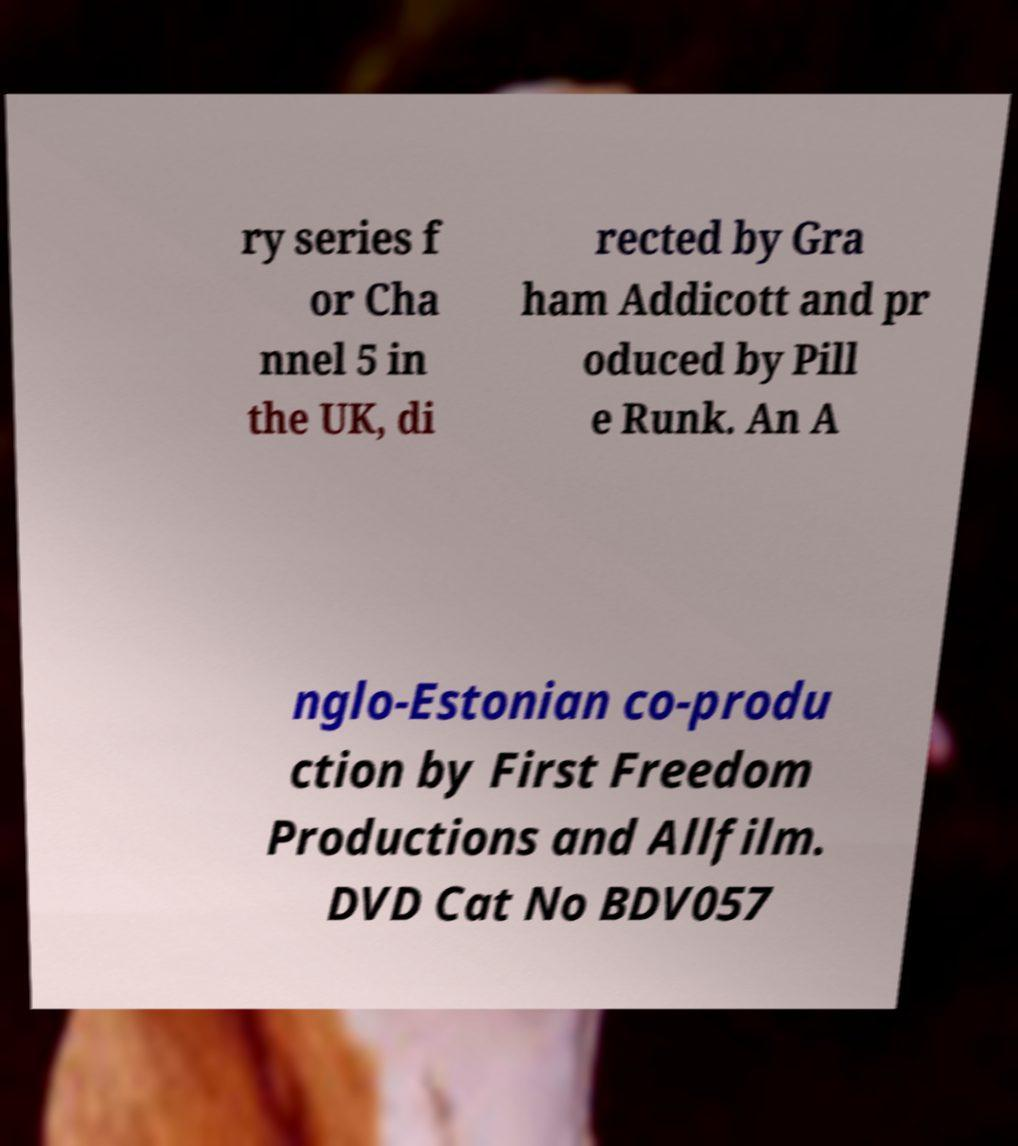What messages or text are displayed in this image? I need them in a readable, typed format. ry series f or Cha nnel 5 in the UK, di rected by Gra ham Addicott and pr oduced by Pill e Runk. An A nglo-Estonian co-produ ction by First Freedom Productions and Allfilm. DVD Cat No BDV057 